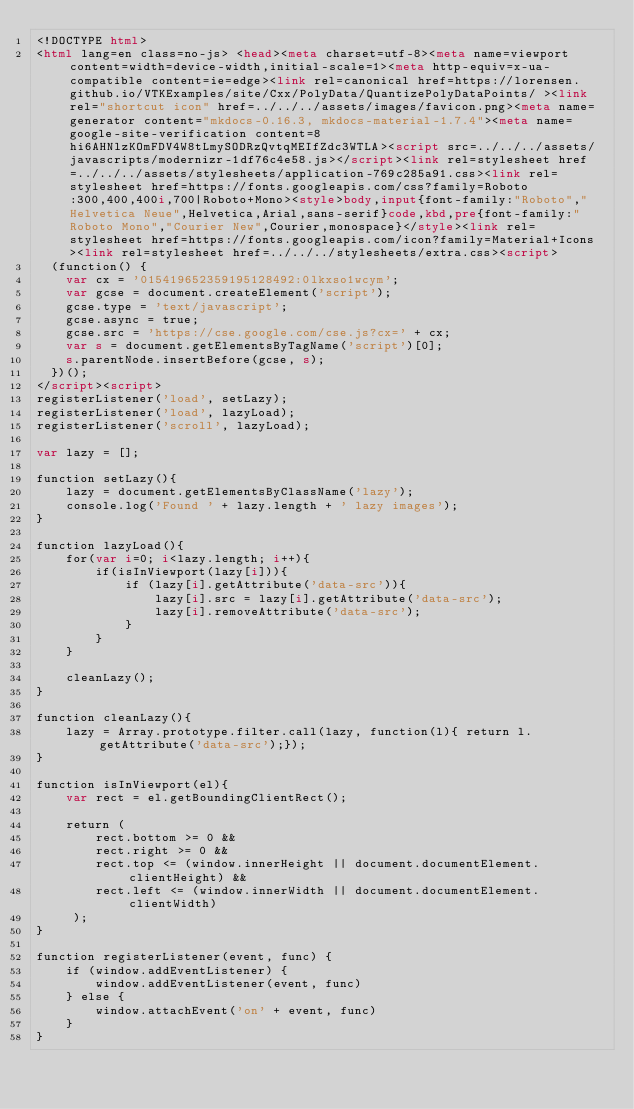Convert code to text. <code><loc_0><loc_0><loc_500><loc_500><_HTML_><!DOCTYPE html>
<html lang=en class=no-js> <head><meta charset=utf-8><meta name=viewport content=width=device-width,initial-scale=1><meta http-equiv=x-ua-compatible content=ie=edge><link rel=canonical href=https://lorensen.github.io/VTKExamples/site/Cxx/PolyData/QuantizePolyDataPoints/ ><link rel="shortcut icon" href=../../../assets/images/favicon.png><meta name=generator content="mkdocs-0.16.3, mkdocs-material-1.7.4"><meta name=google-site-verification content=8hi6AHNlzKOmFDV4W8tLmySODRzQvtqMEIfZdc3WTLA><script src=../../../assets/javascripts/modernizr-1df76c4e58.js></script><link rel=stylesheet href=../../../assets/stylesheets/application-769c285a91.css><link rel=stylesheet href=https://fonts.googleapis.com/css?family=Roboto:300,400,400i,700|Roboto+Mono><style>body,input{font-family:"Roboto","Helvetica Neue",Helvetica,Arial,sans-serif}code,kbd,pre{font-family:"Roboto Mono","Courier New",Courier,monospace}</style><link rel=stylesheet href=https://fonts.googleapis.com/icon?family=Material+Icons><link rel=stylesheet href=../../../stylesheets/extra.css><script>
  (function() {
    var cx = '015419652359195128492:0lkxso1wcym';
    var gcse = document.createElement('script');
    gcse.type = 'text/javascript';
    gcse.async = true;
    gcse.src = 'https://cse.google.com/cse.js?cx=' + cx;
    var s = document.getElementsByTagName('script')[0];
    s.parentNode.insertBefore(gcse, s);
  })();
</script><script>
registerListener('load', setLazy);
registerListener('load', lazyLoad);
registerListener('scroll', lazyLoad);

var lazy = [];

function setLazy(){
    lazy = document.getElementsByClassName('lazy');
    console.log('Found ' + lazy.length + ' lazy images');
} 

function lazyLoad(){
    for(var i=0; i<lazy.length; i++){
        if(isInViewport(lazy[i])){
            if (lazy[i].getAttribute('data-src')){
                lazy[i].src = lazy[i].getAttribute('data-src');
                lazy[i].removeAttribute('data-src');
            }
        }
    }
    
    cleanLazy();
}

function cleanLazy(){
    lazy = Array.prototype.filter.call(lazy, function(l){ return l.getAttribute('data-src');});
}

function isInViewport(el){
    var rect = el.getBoundingClientRect();
    
    return (
        rect.bottom >= 0 && 
        rect.right >= 0 && 
        rect.top <= (window.innerHeight || document.documentElement.clientHeight) && 
        rect.left <= (window.innerWidth || document.documentElement.clientWidth)
     );
}

function registerListener(event, func) {
    if (window.addEventListener) {
        window.addEventListener(event, func)
    } else {
        window.attachEvent('on' + event, func)
    }
}</code> 